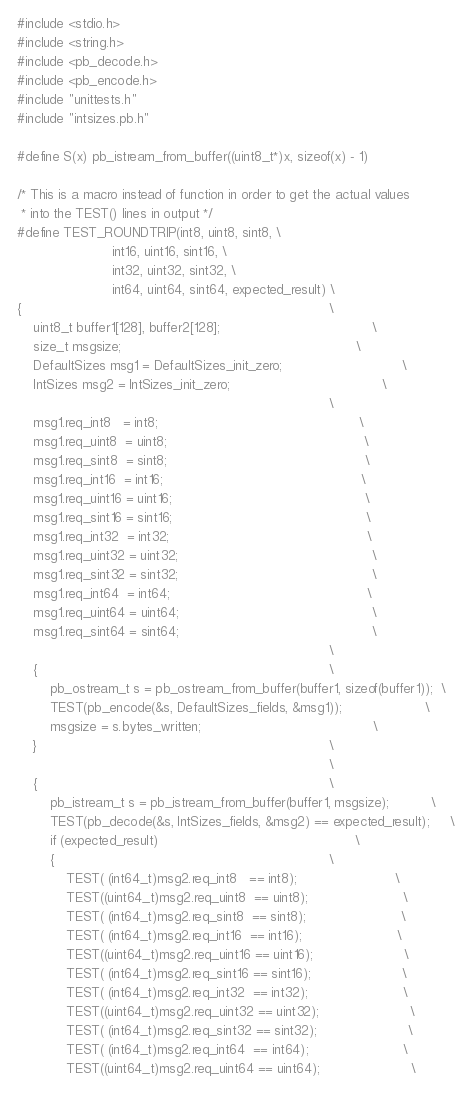<code> <loc_0><loc_0><loc_500><loc_500><_C_>#include <stdio.h>
#include <string.h>
#include <pb_decode.h>
#include <pb_encode.h>
#include "unittests.h"
#include "intsizes.pb.h"

#define S(x) pb_istream_from_buffer((uint8_t*)x, sizeof(x) - 1)

/* This is a macro instead of function in order to get the actual values
 * into the TEST() lines in output */
#define TEST_ROUNDTRIP(int8, uint8, sint8, \
                       int16, uint16, sint16, \
                       int32, uint32, sint32, \
                       int64, uint64, sint64, expected_result) \
{                                                                           \
    uint8_t buffer1[128], buffer2[128];                                     \
    size_t msgsize;                                                         \
    DefaultSizes msg1 = DefaultSizes_init_zero;                             \
    IntSizes msg2 = IntSizes_init_zero;                                     \
                                                                            \
    msg1.req_int8   = int8;                                                 \
    msg1.req_uint8  = uint8;                                                \
    msg1.req_sint8  = sint8;                                                \
    msg1.req_int16  = int16;                                                \
    msg1.req_uint16 = uint16;                                               \
    msg1.req_sint16 = sint16;                                               \
    msg1.req_int32  = int32;                                                \
    msg1.req_uint32 = uint32;                                               \
    msg1.req_sint32 = sint32;                                               \
    msg1.req_int64  = int64;                                                \
    msg1.req_uint64 = uint64;                                               \
    msg1.req_sint64 = sint64;                                               \
                                                                            \
    {                                                                       \
        pb_ostream_t s = pb_ostream_from_buffer(buffer1, sizeof(buffer1));  \
        TEST(pb_encode(&s, DefaultSizes_fields, &msg1));                    \
        msgsize = s.bytes_written;                                          \
    }                                                                       \
                                                                            \
    {                                                                       \
        pb_istream_t s = pb_istream_from_buffer(buffer1, msgsize);          \
        TEST(pb_decode(&s, IntSizes_fields, &msg2) == expected_result);     \
        if (expected_result)                                                \
        {                                                                   \
            TEST( (int64_t)msg2.req_int8   == int8);                        \
            TEST((uint64_t)msg2.req_uint8  == uint8);                       \
            TEST( (int64_t)msg2.req_sint8  == sint8);                       \
            TEST( (int64_t)msg2.req_int16  == int16);                       \
            TEST((uint64_t)msg2.req_uint16 == uint16);                      \
            TEST( (int64_t)msg2.req_sint16 == sint16);                      \
            TEST( (int64_t)msg2.req_int32  == int32);                       \
            TEST((uint64_t)msg2.req_uint32 == uint32);                      \
            TEST( (int64_t)msg2.req_sint32 == sint32);                      \
            TEST( (int64_t)msg2.req_int64  == int64);                       \
            TEST((uint64_t)msg2.req_uint64 == uint64);                      \</code> 